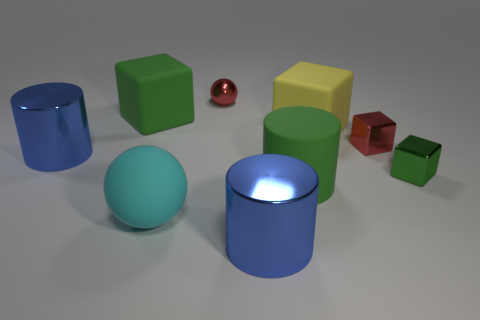Add 1 tiny green blocks. How many objects exist? 10 Subtract all blocks. How many objects are left? 5 Add 3 tiny purple metal cylinders. How many tiny purple metal cylinders exist? 3 Subtract 0 blue cubes. How many objects are left? 9 Subtract all purple rubber cubes. Subtract all large green objects. How many objects are left? 7 Add 2 blue objects. How many blue objects are left? 4 